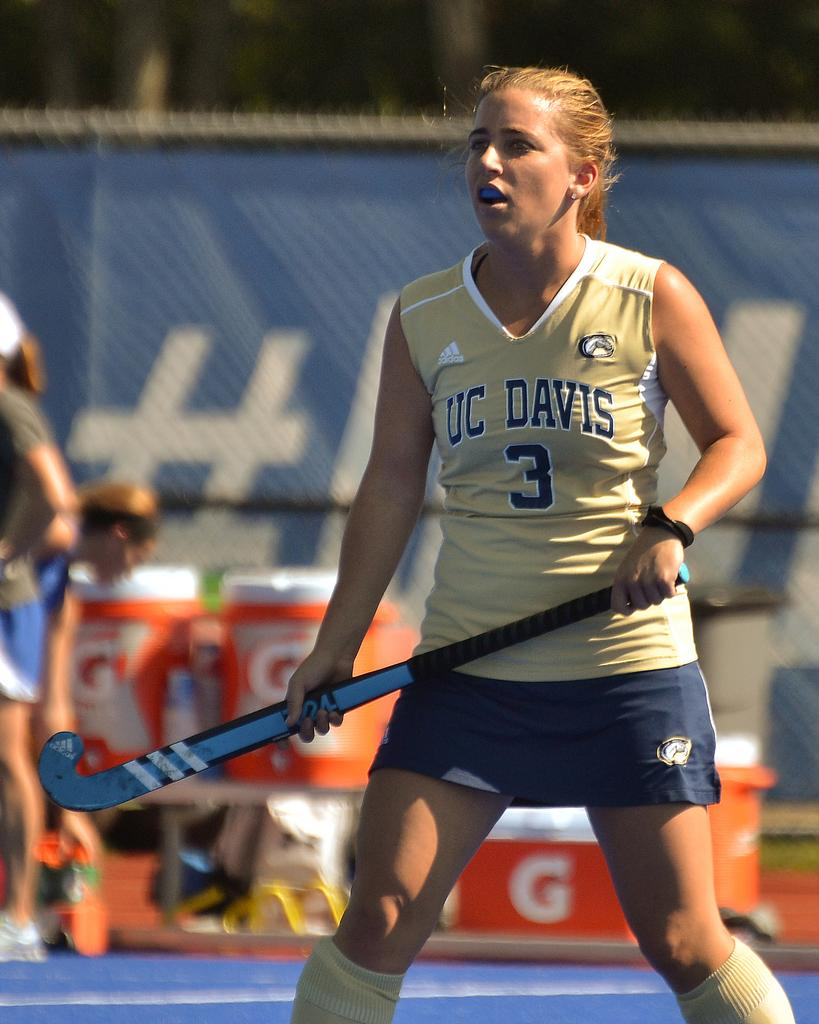<image>
Provide a brief description of the given image. A girl is holding a sports paddle and her uniform says UC Davis 3. 